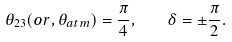Convert formula to latex. <formula><loc_0><loc_0><loc_500><loc_500>\theta _ { 2 3 } ( o r , \theta _ { a t m } ) = \frac { \pi } { 4 } , \quad \delta = \pm \frac { \pi } { 2 } .</formula> 